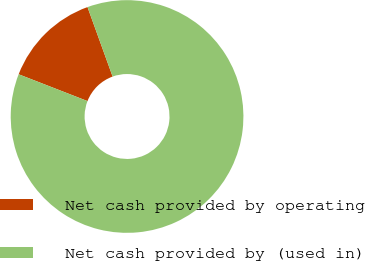Convert chart. <chart><loc_0><loc_0><loc_500><loc_500><pie_chart><fcel>Net cash provided by operating<fcel>Net cash provided by (used in)<nl><fcel>13.57%<fcel>86.43%<nl></chart> 